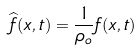Convert formula to latex. <formula><loc_0><loc_0><loc_500><loc_500>\widehat { f } ( x , t ) = \frac { 1 } { \rho _ { o } } f ( x , t )</formula> 